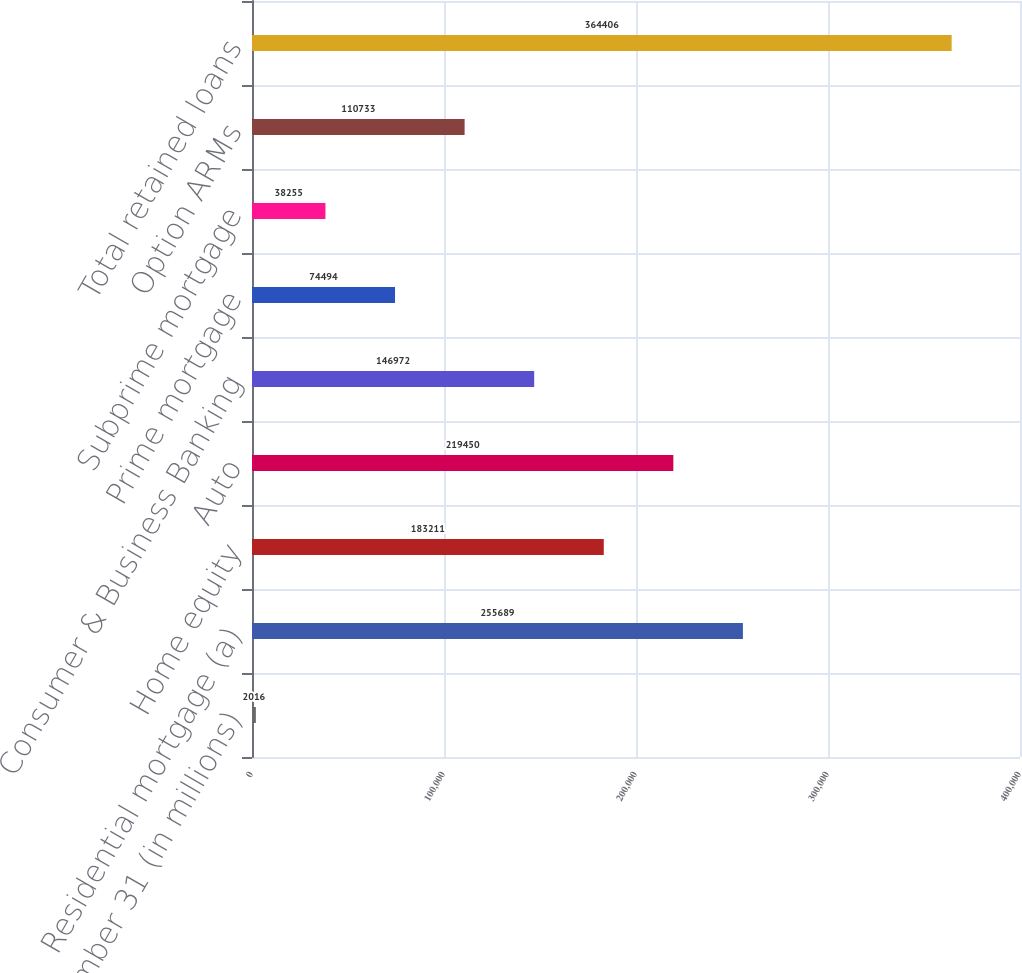Convert chart. <chart><loc_0><loc_0><loc_500><loc_500><bar_chart><fcel>December 31 (in millions)<fcel>Residential mortgage (a)<fcel>Home equity<fcel>Auto<fcel>Consumer & Business Banking<fcel>Prime mortgage<fcel>Subprime mortgage<fcel>Option ARMs<fcel>Total retained loans<nl><fcel>2016<fcel>255689<fcel>183211<fcel>219450<fcel>146972<fcel>74494<fcel>38255<fcel>110733<fcel>364406<nl></chart> 